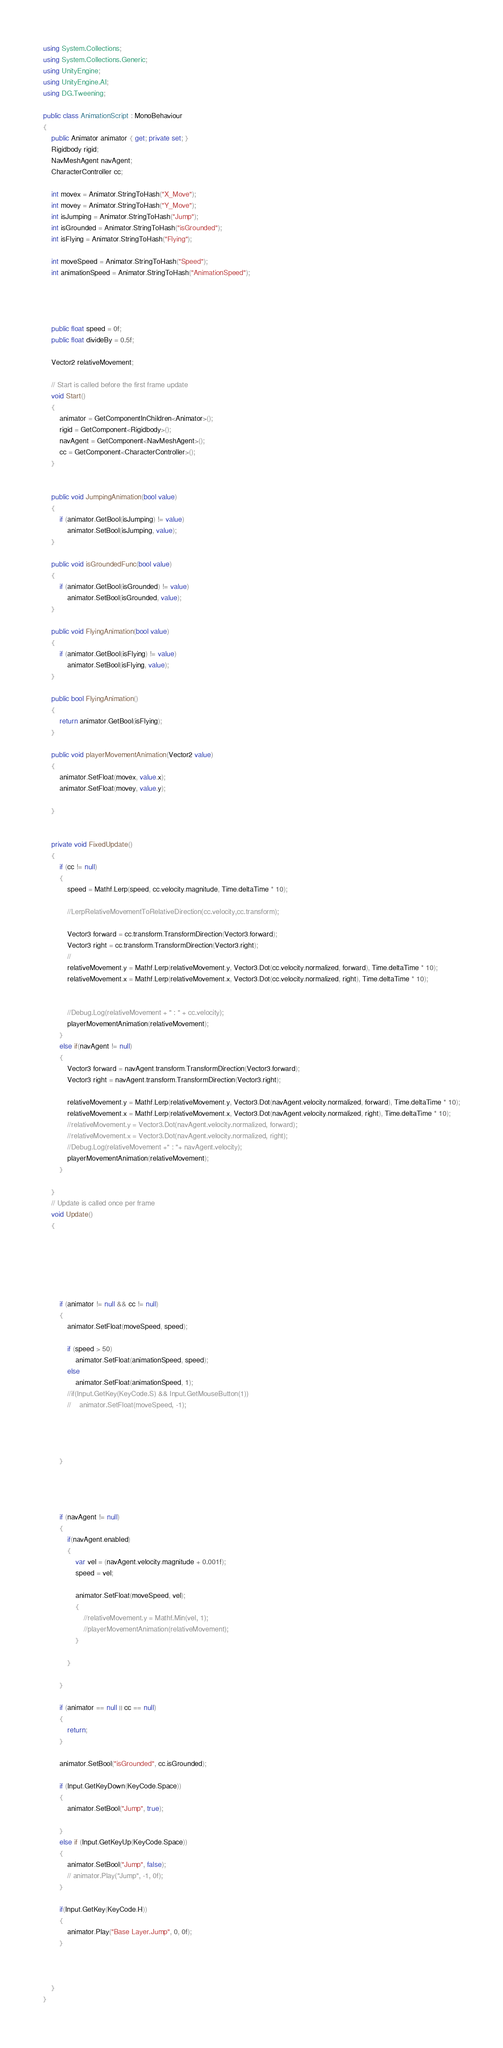Convert code to text. <code><loc_0><loc_0><loc_500><loc_500><_C#_>using System.Collections;
using System.Collections.Generic;
using UnityEngine;
using UnityEngine.AI;
using DG.Tweening;

public class AnimationScript : MonoBehaviour
{
    public Animator animator { get; private set; }
    Rigidbody rigid;
    NavMeshAgent navAgent;
    CharacterController cc;

    int movex = Animator.StringToHash("X_Move");
    int movey = Animator.StringToHash("Y_Move");
    int isJumping = Animator.StringToHash("Jump");
    int isGrounded = Animator.StringToHash("isGrounded");
    int isFlying = Animator.StringToHash("Flying");

    int moveSpeed = Animator.StringToHash("Speed");
    int animationSpeed = Animator.StringToHash("AnimationSpeed");




    public float speed = 0f;
    public float divideBy = 0.5f;

    Vector2 relativeMovement;

    // Start is called before the first frame update
    void Start()
    {
        animator = GetComponentInChildren<Animator>();
        rigid = GetComponent<Rigidbody>();
        navAgent = GetComponent<NavMeshAgent>();
        cc = GetComponent<CharacterController>();
    }


    public void JumpingAnimation(bool value)
    {
        if (animator.GetBool(isJumping) != value)
            animator.SetBool(isJumping, value);
    }

    public void isGroundedFunc(bool value)
    {
        if (animator.GetBool(isGrounded) != value)
            animator.SetBool(isGrounded, value);
    }

    public void FlyingAnimation(bool value)
    {
        if (animator.GetBool(isFlying) != value)
            animator.SetBool(isFlying, value);
    }

    public bool FlyingAnimation()
    {
        return animator.GetBool(isFlying);
    }

    public void playerMovementAnimation(Vector2 value)
    {
        animator.SetFloat(movex, value.x);
        animator.SetFloat(movey, value.y);
        
    }


    private void FixedUpdate()
    {
        if (cc != null)
        {
            speed = Mathf.Lerp(speed, cc.velocity.magnitude, Time.deltaTime * 10);

            //LerpRelativeMovementToRelativeDirection(cc.velocity,cc.transform);

            Vector3 forward = cc.transform.TransformDirection(Vector3.forward);
            Vector3 right = cc.transform.TransformDirection(Vector3.right);
            // 
            relativeMovement.y = Mathf.Lerp(relativeMovement.y, Vector3.Dot(cc.velocity.normalized, forward), Time.deltaTime * 10);
            relativeMovement.x = Mathf.Lerp(relativeMovement.x, Vector3.Dot(cc.velocity.normalized, right), Time.deltaTime * 10);


            //Debug.Log(relativeMovement + " : " + cc.velocity);
            playerMovementAnimation(relativeMovement);
        }
        else if(navAgent != null)
        {
            Vector3 forward = navAgent.transform.TransformDirection(Vector3.forward);
            Vector3 right = navAgent.transform.TransformDirection(Vector3.right);

            relativeMovement.y = Mathf.Lerp(relativeMovement.y, Vector3.Dot(navAgent.velocity.normalized, forward), Time.deltaTime * 10);
            relativeMovement.x = Mathf.Lerp(relativeMovement.x, Vector3.Dot(navAgent.velocity.normalized, right), Time.deltaTime * 10);
            //relativeMovement.y = Vector3.Dot(navAgent.velocity.normalized, forward);
            //relativeMovement.x = Vector3.Dot(navAgent.velocity.normalized, right);
            //Debug.Log(relativeMovement +" : "+ navAgent.velocity);
            playerMovementAnimation(relativeMovement);
        }
        
    }
    // Update is called once per frame
    void Update()
    {
        
            

        


        if (animator != null && cc != null)
        {
            animator.SetFloat(moveSpeed, speed);
            
            if (speed > 50)
                animator.SetFloat(animationSpeed, speed);
            else
                animator.SetFloat(animationSpeed, 1);
            //if(Input.GetKey(KeyCode.S) && Input.GetMouseButton(1))
            //    animator.SetFloat(moveSpeed, -1);

            


        }
            

        

        if (navAgent != null)
        {
            if(navAgent.enabled)
            {
                var vel = (navAgent.velocity.magnitude + 0.001f);
                speed = vel;

                animator.SetFloat(moveSpeed, vel);
                {
                    //relativeMovement.y = Mathf.Min(vel, 1);
                    //playerMovementAnimation(relativeMovement);
                }
                    
            }
            
        }

        if (animator == null || cc == null)
        {
            return;
        }

        animator.SetBool("isGrounded", cc.isGrounded);

        if (Input.GetKeyDown(KeyCode.Space))
        {
            animator.SetBool("Jump", true);
            
        }
        else if (Input.GetKeyUp(KeyCode.Space))
        {
            animator.SetBool("Jump", false);
            // animator.Play("Jump", -1, 0f);
        }

        if(Input.GetKey(KeyCode.H))
        {
            animator.Play("Base Layer.Jump", 0, 0f);
        }
            


    }
}
</code> 